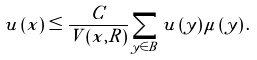<formula> <loc_0><loc_0><loc_500><loc_500>u \left ( x \right ) \leq \frac { C } { V \left ( x , R \right ) } \sum _ { y \in B } u \left ( y \right ) \mu \left ( y \right ) .</formula> 